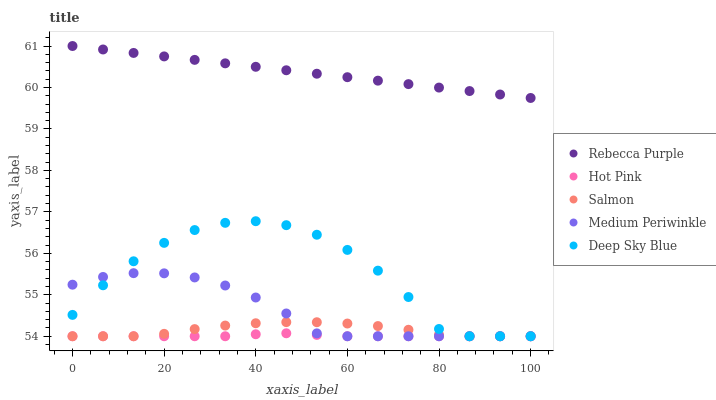Does Hot Pink have the minimum area under the curve?
Answer yes or no. Yes. Does Rebecca Purple have the maximum area under the curve?
Answer yes or no. Yes. Does Salmon have the minimum area under the curve?
Answer yes or no. No. Does Salmon have the maximum area under the curve?
Answer yes or no. No. Is Rebecca Purple the smoothest?
Answer yes or no. Yes. Is Deep Sky Blue the roughest?
Answer yes or no. Yes. Is Hot Pink the smoothest?
Answer yes or no. No. Is Hot Pink the roughest?
Answer yes or no. No. Does Medium Periwinkle have the lowest value?
Answer yes or no. Yes. Does Rebecca Purple have the lowest value?
Answer yes or no. No. Does Rebecca Purple have the highest value?
Answer yes or no. Yes. Does Salmon have the highest value?
Answer yes or no. No. Is Deep Sky Blue less than Rebecca Purple?
Answer yes or no. Yes. Is Rebecca Purple greater than Medium Periwinkle?
Answer yes or no. Yes. Does Deep Sky Blue intersect Medium Periwinkle?
Answer yes or no. Yes. Is Deep Sky Blue less than Medium Periwinkle?
Answer yes or no. No. Is Deep Sky Blue greater than Medium Periwinkle?
Answer yes or no. No. Does Deep Sky Blue intersect Rebecca Purple?
Answer yes or no. No. 